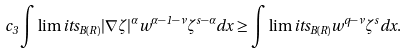Convert formula to latex. <formula><loc_0><loc_0><loc_500><loc_500>c _ { 3 } \int \lim i t s _ { B ( R ) } | \nabla \zeta | ^ { \alpha } w ^ { \alpha - 1 - \nu } \zeta ^ { s - \alpha } d x \geq \int \lim i t s _ { B ( R ) } w ^ { q - \nu } \zeta ^ { s } d x .</formula> 